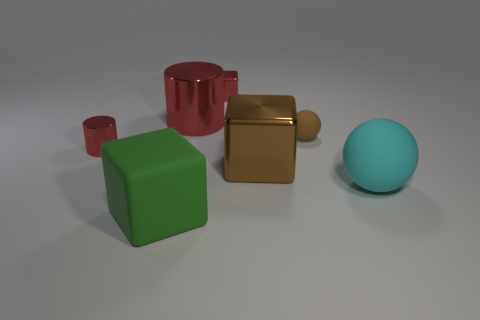How many red cylinders must be subtracted to get 1 red cylinders? 1 Subtract all metallic cubes. How many cubes are left? 1 Subtract 1 cubes. How many cubes are left? 2 Subtract all brown spheres. How many spheres are left? 1 Add 2 blue rubber objects. How many objects exist? 9 Subtract all brown blocks. Subtract all big gray shiny balls. How many objects are left? 6 Add 7 green blocks. How many green blocks are left? 8 Add 5 balls. How many balls exist? 7 Subtract 1 green cubes. How many objects are left? 6 Subtract all blocks. How many objects are left? 4 